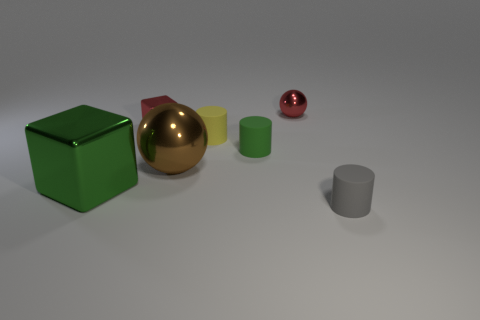There is a tiny rubber object that is behind the green thing that is on the right side of the big ball; what is its shape?
Make the answer very short. Cylinder. Does the brown shiny sphere have the same size as the green thing that is in front of the brown metallic ball?
Offer a very short reply. Yes. There is a small red object that is in front of the red ball; what material is it?
Provide a succinct answer. Metal. How many things are in front of the red sphere and to the left of the small gray matte cylinder?
Ensure brevity in your answer.  5. There is a green cylinder that is the same size as the yellow matte thing; what material is it?
Provide a succinct answer. Rubber. There is a metallic cube behind the large brown object; is it the same size as the cylinder that is in front of the green metal object?
Your response must be concise. Yes. Are there any gray matte objects behind the small gray cylinder?
Offer a terse response. No. What color is the tiny cylinder in front of the big metal object that is in front of the big brown ball?
Your response must be concise. Gray. Is the number of small matte objects less than the number of brown shiny spheres?
Your answer should be compact. No. What number of large brown metal things have the same shape as the green rubber object?
Your response must be concise. 0. 